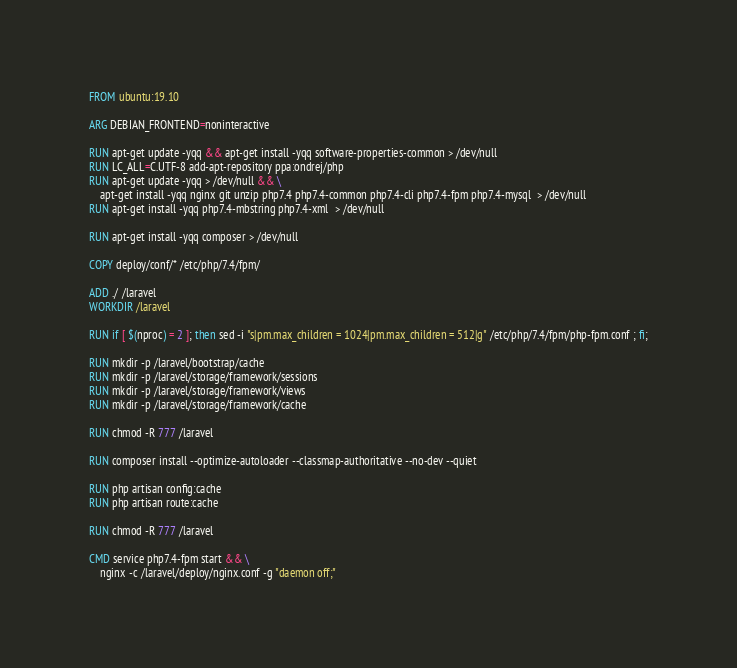Convert code to text. <code><loc_0><loc_0><loc_500><loc_500><_Dockerfile_>FROM ubuntu:19.10

ARG DEBIAN_FRONTEND=noninteractive

RUN apt-get update -yqq && apt-get install -yqq software-properties-common > /dev/null
RUN LC_ALL=C.UTF-8 add-apt-repository ppa:ondrej/php
RUN apt-get update -yqq > /dev/null && \
    apt-get install -yqq nginx git unzip php7.4 php7.4-common php7.4-cli php7.4-fpm php7.4-mysql  > /dev/null
RUN apt-get install -yqq php7.4-mbstring php7.4-xml  > /dev/null

RUN apt-get install -yqq composer > /dev/null

COPY deploy/conf/* /etc/php/7.4/fpm/

ADD ./ /laravel
WORKDIR /laravel

RUN if [ $(nproc) = 2 ]; then sed -i "s|pm.max_children = 1024|pm.max_children = 512|g" /etc/php/7.4/fpm/php-fpm.conf ; fi;

RUN mkdir -p /laravel/bootstrap/cache
RUN mkdir -p /laravel/storage/framework/sessions
RUN mkdir -p /laravel/storage/framework/views
RUN mkdir -p /laravel/storage/framework/cache

RUN chmod -R 777 /laravel

RUN composer install --optimize-autoloader --classmap-authoritative --no-dev --quiet

RUN php artisan config:cache
RUN php artisan route:cache

RUN chmod -R 777 /laravel

CMD service php7.4-fpm start && \
    nginx -c /laravel/deploy/nginx.conf -g "daemon off;"
</code> 